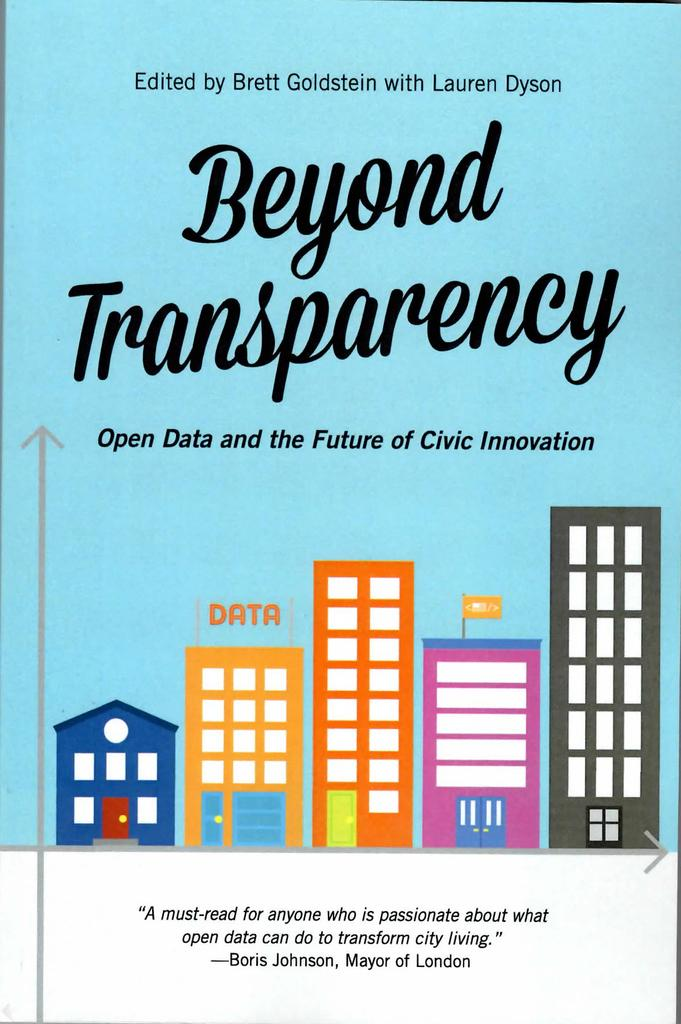<image>
Offer a succinct explanation of the picture presented. The book cover for Beyond Transparency features a quote by Boris Johnson. 